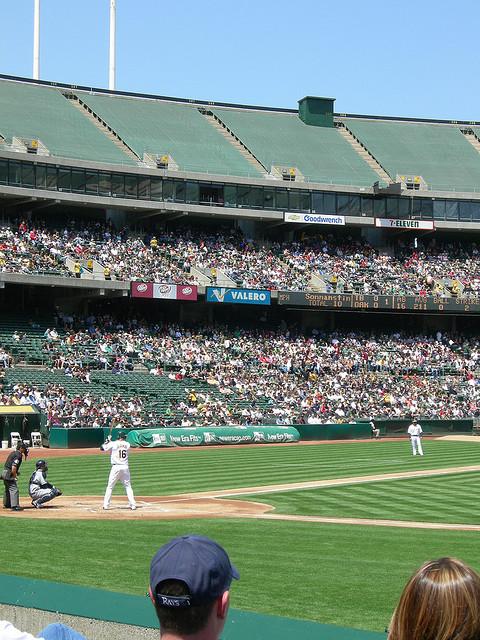Is the stadium full?
Be succinct. No. Is the game starting?
Write a very short answer. Yes. What sport are the people in this photograph playing?
Quick response, please. Baseball. What color cap is the man in the right foreground wearing?
Give a very brief answer. Blue. 